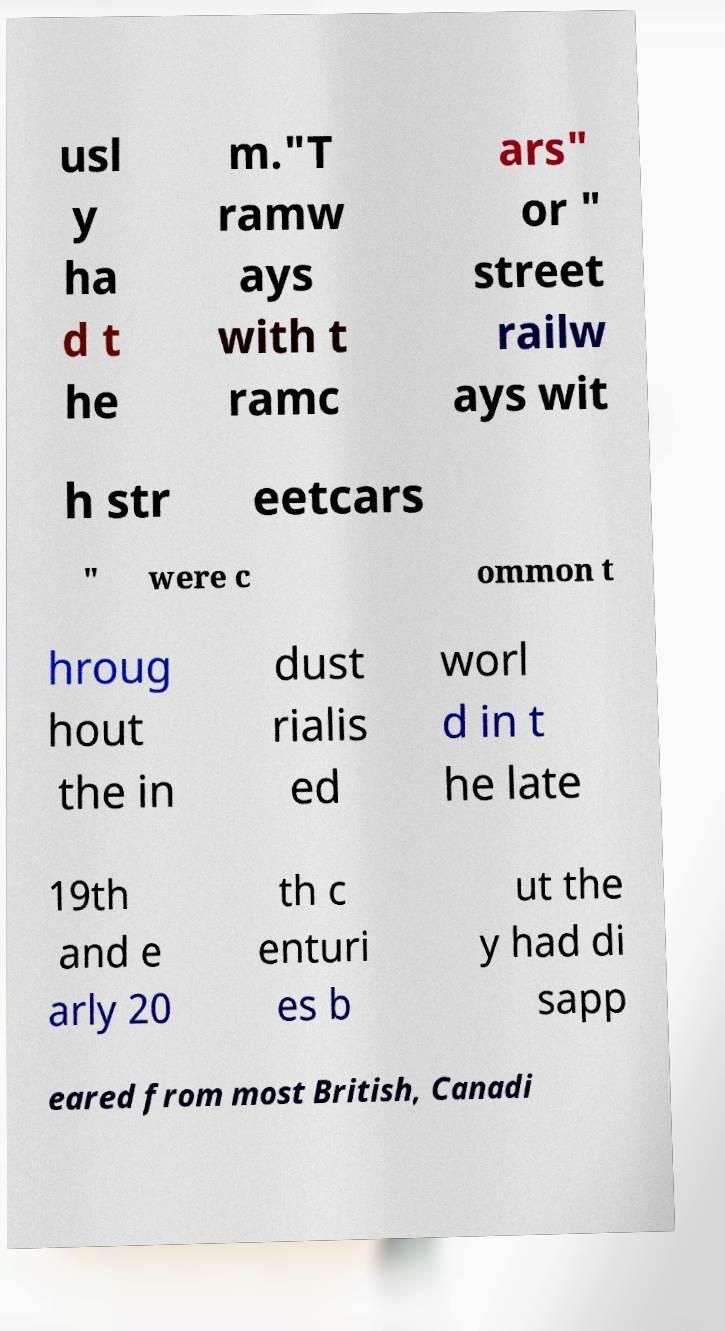Can you read and provide the text displayed in the image?This photo seems to have some interesting text. Can you extract and type it out for me? usl y ha d t he m."T ramw ays with t ramc ars" or " street railw ays wit h str eetcars " were c ommon t hroug hout the in dust rialis ed worl d in t he late 19th and e arly 20 th c enturi es b ut the y had di sapp eared from most British, Canadi 